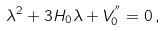<formula> <loc_0><loc_0><loc_500><loc_500>\lambda ^ { 2 } + 3 H _ { 0 } \lambda + V _ { 0 } ^ { ^ { \prime \prime } } = 0 \, ,</formula> 